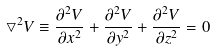<formula> <loc_0><loc_0><loc_500><loc_500>\bigtriangledown ^ { 2 } V \equiv \frac { \partial ^ { 2 } V } { \partial x ^ { 2 } } + \frac { \partial ^ { 2 } V } { \partial y ^ { 2 } } + \frac { \partial ^ { 2 } V } { \partial z ^ { 2 } } = 0</formula> 